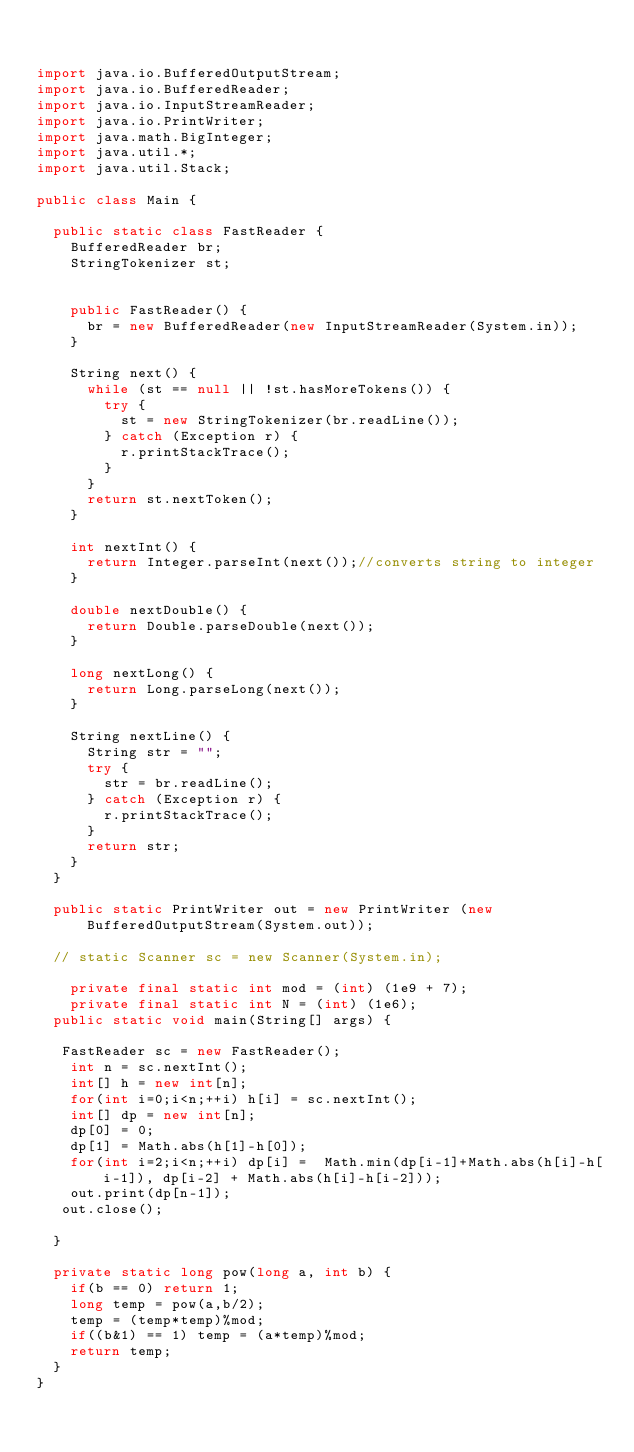<code> <loc_0><loc_0><loc_500><loc_500><_Java_>

import java.io.BufferedOutputStream;
import java.io.BufferedReader;
import java.io.InputStreamReader;
import java.io.PrintWriter;
import java.math.BigInteger;
import java.util.*;
import java.util.Stack;

public class Main {
	
	public static class FastReader {
		BufferedReader br;
		StringTokenizer st;
	

		public FastReader() {
			br = new BufferedReader(new InputStreamReader(System.in));
		}

		String next() {
			while (st == null || !st.hasMoreTokens()) {
				try {
					st = new StringTokenizer(br.readLine());
				} catch (Exception r) {
					r.printStackTrace();
				}
			}
			return st.nextToken();
		}

		int nextInt() {
			return Integer.parseInt(next());//converts string to integer
		}

		double nextDouble() {
			return Double.parseDouble(next());
		}

		long nextLong() {
			return Long.parseLong(next());
		}

		String nextLine() {
			String str = "";
			try {
				str = br.readLine();
			} catch (Exception r) {
				r.printStackTrace();
			}
			return str;
		}
	}
	
	public static PrintWriter out = new PrintWriter (new BufferedOutputStream(System.out));
   
  // static Scanner sc = new Scanner(System.in);
  
    private final static int mod = (int) (1e9 + 7);
    private final static int N = (int) (1e6);
	public static void main(String[] args) {
	   
	 FastReader sc = new FastReader();
		int n = sc.nextInt();
		int[] h = new int[n];
		for(int i=0;i<n;++i) h[i] = sc.nextInt();
		int[] dp = new int[n];
		dp[0] = 0;
		dp[1] = Math.abs(h[1]-h[0]);
		for(int i=2;i<n;++i) dp[i] =  Math.min(dp[i-1]+Math.abs(h[i]-h[i-1]), dp[i-2] + Math.abs(h[i]-h[i-2]));
		out.print(dp[n-1]);
	 out.close();
    
	}

	private static long pow(long a, int b) {
		if(b == 0) return 1;
		long temp = pow(a,b/2);
		temp = (temp*temp)%mod;
		if((b&1) == 1) temp = (a*temp)%mod;
		return temp;
	}
}</code> 